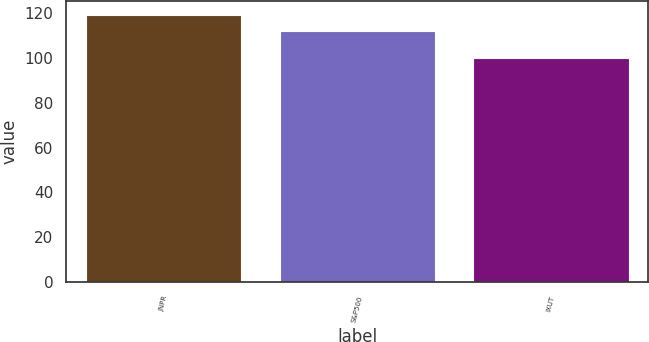Convert chart. <chart><loc_0><loc_0><loc_500><loc_500><bar_chart><fcel>JNPR<fcel>S&P500<fcel>IXUT<nl><fcel>119.38<fcel>112.26<fcel>100.21<nl></chart> 